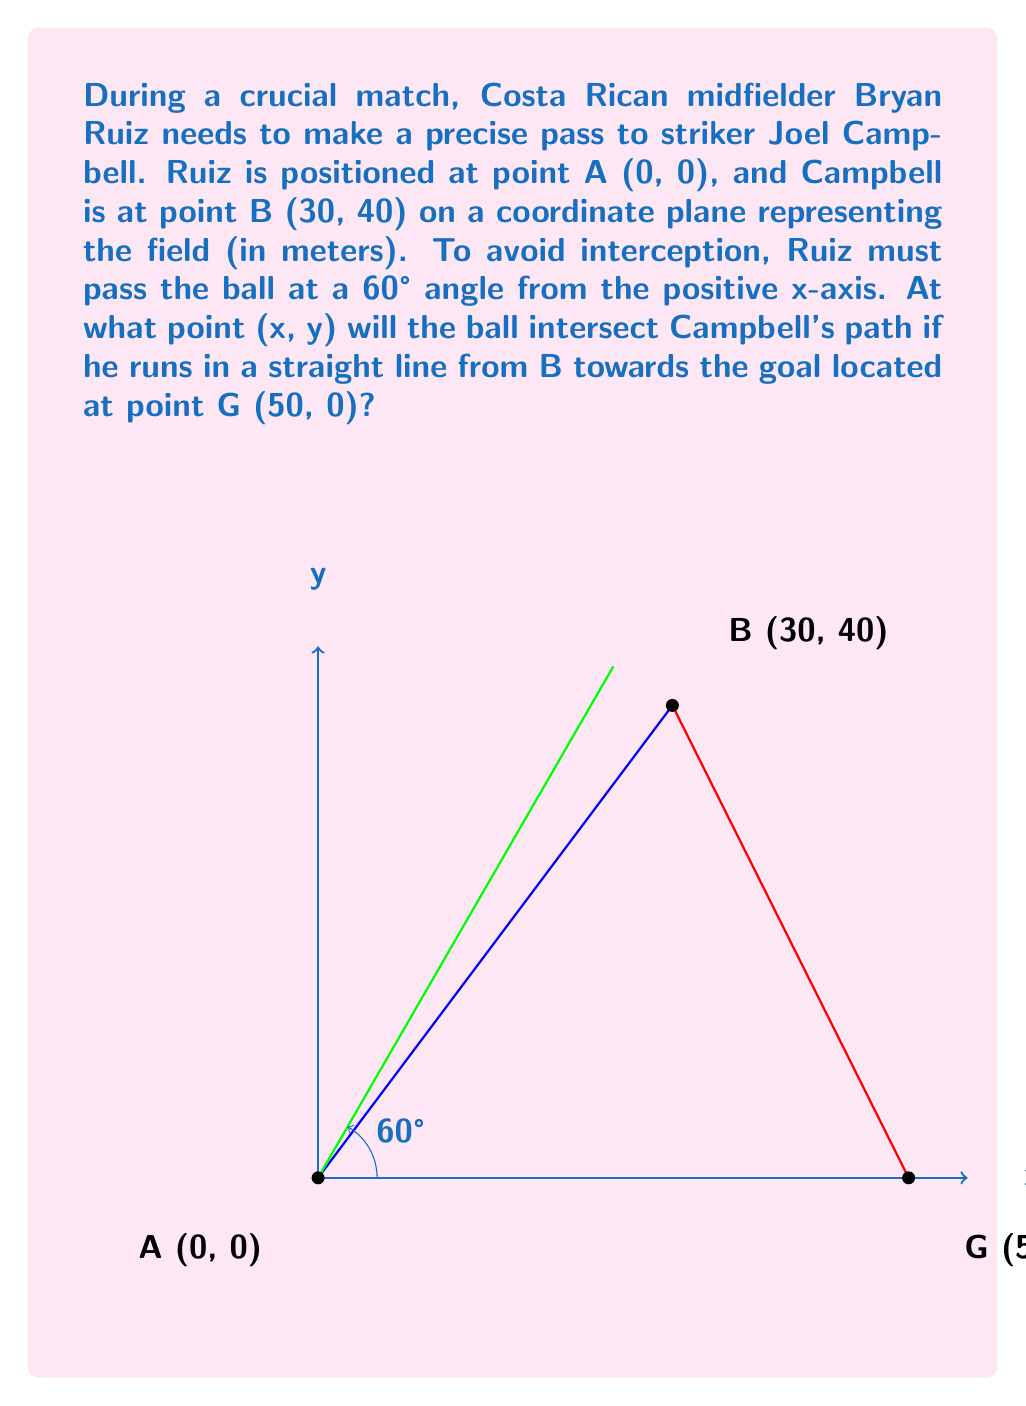What is the answer to this math problem? Let's approach this step-by-step:

1) The line from A at a 60° angle can be represented by the equation:
   $y = \tan(60°) \cdot x = \sqrt{3} \cdot x$

2) The line from B to G can be represented by:
   $y = mx + b$, where $m$ is the slope and $b$ is the y-intercept.

3) Calculate the slope (m):
   $m = \frac{y_G - y_B}{x_G - x_B} = \frac{0 - 40}{50 - 30} = -2$

4) Find the y-intercept (b):
   $40 = -2(30) + b$
   $b = 100$

   So, the equation of line BG is: $y = -2x + 100$

5) The intersection point is where these two lines meet. Set them equal:
   $\sqrt{3} \cdot x = -2x + 100$

6) Solve for x:
   $3\sqrt{3} \cdot x = -6x + 300$
   $9x + 6x = 300$
   $15x = 300$
   $x = 20$

7) Substitute this x-value back into either equation to find y:
   $y = \sqrt{3} \cdot 20 \approx 34.64$

Therefore, the ball will intersect Campbell's path at approximately (20, 34.64).
Answer: (20, 34.64) 